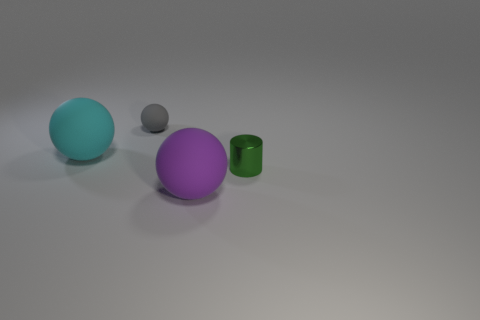There is a large ball that is in front of the small thing right of the purple ball; what is its material?
Provide a short and direct response. Rubber. What number of objects are blue shiny things or cyan objects?
Keep it short and to the point. 1. Is the number of large purple rubber balls less than the number of big gray metal spheres?
Ensure brevity in your answer.  No. What size is the cyan thing that is made of the same material as the tiny ball?
Provide a succinct answer. Large. What size is the cyan rubber thing?
Offer a terse response. Large. What shape is the metallic object?
Ensure brevity in your answer.  Cylinder. Does the small object behind the cylinder have the same color as the small metallic cylinder?
Give a very brief answer. No. There is a cyan rubber object that is the same shape as the gray rubber thing; what size is it?
Give a very brief answer. Large. Is there any other thing that is made of the same material as the gray thing?
Give a very brief answer. Yes. Is there a large purple matte ball that is right of the large matte object behind the purple rubber sphere that is in front of the cyan rubber thing?
Provide a short and direct response. Yes. 